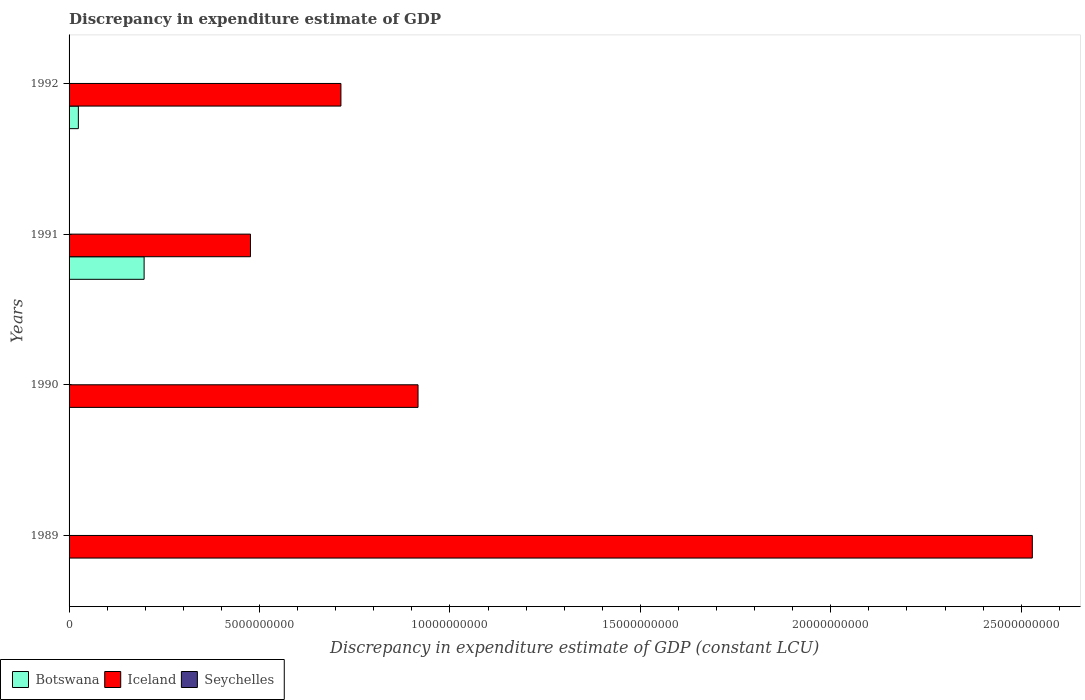Are the number of bars per tick equal to the number of legend labels?
Offer a very short reply. No. How many bars are there on the 2nd tick from the top?
Your answer should be compact. 2. What is the label of the 3rd group of bars from the top?
Offer a very short reply. 1990. In how many cases, is the number of bars for a given year not equal to the number of legend labels?
Give a very brief answer. 4. What is the discrepancy in expenditure estimate of GDP in Iceland in 1989?
Give a very brief answer. 2.53e+1. Across all years, what is the maximum discrepancy in expenditure estimate of GDP in Botswana?
Give a very brief answer. 1.97e+09. Across all years, what is the minimum discrepancy in expenditure estimate of GDP in Iceland?
Ensure brevity in your answer.  4.76e+09. In which year was the discrepancy in expenditure estimate of GDP in Botswana maximum?
Provide a succinct answer. 1991. What is the total discrepancy in expenditure estimate of GDP in Iceland in the graph?
Offer a very short reply. 4.64e+1. What is the difference between the discrepancy in expenditure estimate of GDP in Iceland in 1990 and that in 1991?
Provide a succinct answer. 4.40e+09. What is the difference between the discrepancy in expenditure estimate of GDP in Iceland in 1991 and the discrepancy in expenditure estimate of GDP in Seychelles in 1989?
Offer a very short reply. 4.76e+09. What is the average discrepancy in expenditure estimate of GDP in Seychelles per year?
Offer a very short reply. 0. In the year 1992, what is the difference between the discrepancy in expenditure estimate of GDP in Iceland and discrepancy in expenditure estimate of GDP in Botswana?
Your response must be concise. 6.89e+09. What is the ratio of the discrepancy in expenditure estimate of GDP in Iceland in 1989 to that in 1990?
Offer a terse response. 2.76. What is the difference between the highest and the second highest discrepancy in expenditure estimate of GDP in Iceland?
Provide a short and direct response. 1.61e+1. What is the difference between the highest and the lowest discrepancy in expenditure estimate of GDP in Botswana?
Ensure brevity in your answer.  1.97e+09. Is it the case that in every year, the sum of the discrepancy in expenditure estimate of GDP in Botswana and discrepancy in expenditure estimate of GDP in Iceland is greater than the discrepancy in expenditure estimate of GDP in Seychelles?
Keep it short and to the point. Yes. How many bars are there?
Your response must be concise. 6. What is the difference between two consecutive major ticks on the X-axis?
Provide a short and direct response. 5.00e+09. Are the values on the major ticks of X-axis written in scientific E-notation?
Keep it short and to the point. No. Does the graph contain grids?
Keep it short and to the point. No. How are the legend labels stacked?
Your answer should be compact. Horizontal. What is the title of the graph?
Provide a succinct answer. Discrepancy in expenditure estimate of GDP. What is the label or title of the X-axis?
Your answer should be compact. Discrepancy in expenditure estimate of GDP (constant LCU). What is the Discrepancy in expenditure estimate of GDP (constant LCU) in Botswana in 1989?
Provide a short and direct response. 0. What is the Discrepancy in expenditure estimate of GDP (constant LCU) in Iceland in 1989?
Ensure brevity in your answer.  2.53e+1. What is the Discrepancy in expenditure estimate of GDP (constant LCU) of Iceland in 1990?
Provide a short and direct response. 9.16e+09. What is the Discrepancy in expenditure estimate of GDP (constant LCU) in Botswana in 1991?
Your response must be concise. 1.97e+09. What is the Discrepancy in expenditure estimate of GDP (constant LCU) of Iceland in 1991?
Your answer should be compact. 4.76e+09. What is the Discrepancy in expenditure estimate of GDP (constant LCU) of Botswana in 1992?
Your response must be concise. 2.44e+08. What is the Discrepancy in expenditure estimate of GDP (constant LCU) of Iceland in 1992?
Your answer should be very brief. 7.14e+09. Across all years, what is the maximum Discrepancy in expenditure estimate of GDP (constant LCU) of Botswana?
Your answer should be very brief. 1.97e+09. Across all years, what is the maximum Discrepancy in expenditure estimate of GDP (constant LCU) of Iceland?
Offer a very short reply. 2.53e+1. Across all years, what is the minimum Discrepancy in expenditure estimate of GDP (constant LCU) of Iceland?
Offer a very short reply. 4.76e+09. What is the total Discrepancy in expenditure estimate of GDP (constant LCU) in Botswana in the graph?
Provide a short and direct response. 2.21e+09. What is the total Discrepancy in expenditure estimate of GDP (constant LCU) in Iceland in the graph?
Ensure brevity in your answer.  4.64e+1. What is the difference between the Discrepancy in expenditure estimate of GDP (constant LCU) in Iceland in 1989 and that in 1990?
Give a very brief answer. 1.61e+1. What is the difference between the Discrepancy in expenditure estimate of GDP (constant LCU) of Iceland in 1989 and that in 1991?
Keep it short and to the point. 2.05e+1. What is the difference between the Discrepancy in expenditure estimate of GDP (constant LCU) in Iceland in 1989 and that in 1992?
Offer a very short reply. 1.82e+1. What is the difference between the Discrepancy in expenditure estimate of GDP (constant LCU) in Iceland in 1990 and that in 1991?
Offer a terse response. 4.40e+09. What is the difference between the Discrepancy in expenditure estimate of GDP (constant LCU) of Iceland in 1990 and that in 1992?
Keep it short and to the point. 2.02e+09. What is the difference between the Discrepancy in expenditure estimate of GDP (constant LCU) in Botswana in 1991 and that in 1992?
Your answer should be compact. 1.73e+09. What is the difference between the Discrepancy in expenditure estimate of GDP (constant LCU) in Iceland in 1991 and that in 1992?
Your answer should be very brief. -2.37e+09. What is the difference between the Discrepancy in expenditure estimate of GDP (constant LCU) of Botswana in 1991 and the Discrepancy in expenditure estimate of GDP (constant LCU) of Iceland in 1992?
Ensure brevity in your answer.  -5.17e+09. What is the average Discrepancy in expenditure estimate of GDP (constant LCU) of Botswana per year?
Your answer should be compact. 5.54e+08. What is the average Discrepancy in expenditure estimate of GDP (constant LCU) in Iceland per year?
Your response must be concise. 1.16e+1. In the year 1991, what is the difference between the Discrepancy in expenditure estimate of GDP (constant LCU) in Botswana and Discrepancy in expenditure estimate of GDP (constant LCU) in Iceland?
Provide a succinct answer. -2.79e+09. In the year 1992, what is the difference between the Discrepancy in expenditure estimate of GDP (constant LCU) of Botswana and Discrepancy in expenditure estimate of GDP (constant LCU) of Iceland?
Your answer should be very brief. -6.89e+09. What is the ratio of the Discrepancy in expenditure estimate of GDP (constant LCU) in Iceland in 1989 to that in 1990?
Your response must be concise. 2.76. What is the ratio of the Discrepancy in expenditure estimate of GDP (constant LCU) of Iceland in 1989 to that in 1991?
Give a very brief answer. 5.31. What is the ratio of the Discrepancy in expenditure estimate of GDP (constant LCU) in Iceland in 1989 to that in 1992?
Offer a terse response. 3.54. What is the ratio of the Discrepancy in expenditure estimate of GDP (constant LCU) in Iceland in 1990 to that in 1991?
Give a very brief answer. 1.92. What is the ratio of the Discrepancy in expenditure estimate of GDP (constant LCU) of Iceland in 1990 to that in 1992?
Offer a terse response. 1.28. What is the ratio of the Discrepancy in expenditure estimate of GDP (constant LCU) in Botswana in 1991 to that in 1992?
Provide a short and direct response. 8.07. What is the ratio of the Discrepancy in expenditure estimate of GDP (constant LCU) of Iceland in 1991 to that in 1992?
Provide a succinct answer. 0.67. What is the difference between the highest and the second highest Discrepancy in expenditure estimate of GDP (constant LCU) of Iceland?
Offer a terse response. 1.61e+1. What is the difference between the highest and the lowest Discrepancy in expenditure estimate of GDP (constant LCU) of Botswana?
Ensure brevity in your answer.  1.97e+09. What is the difference between the highest and the lowest Discrepancy in expenditure estimate of GDP (constant LCU) in Iceland?
Offer a terse response. 2.05e+1. 